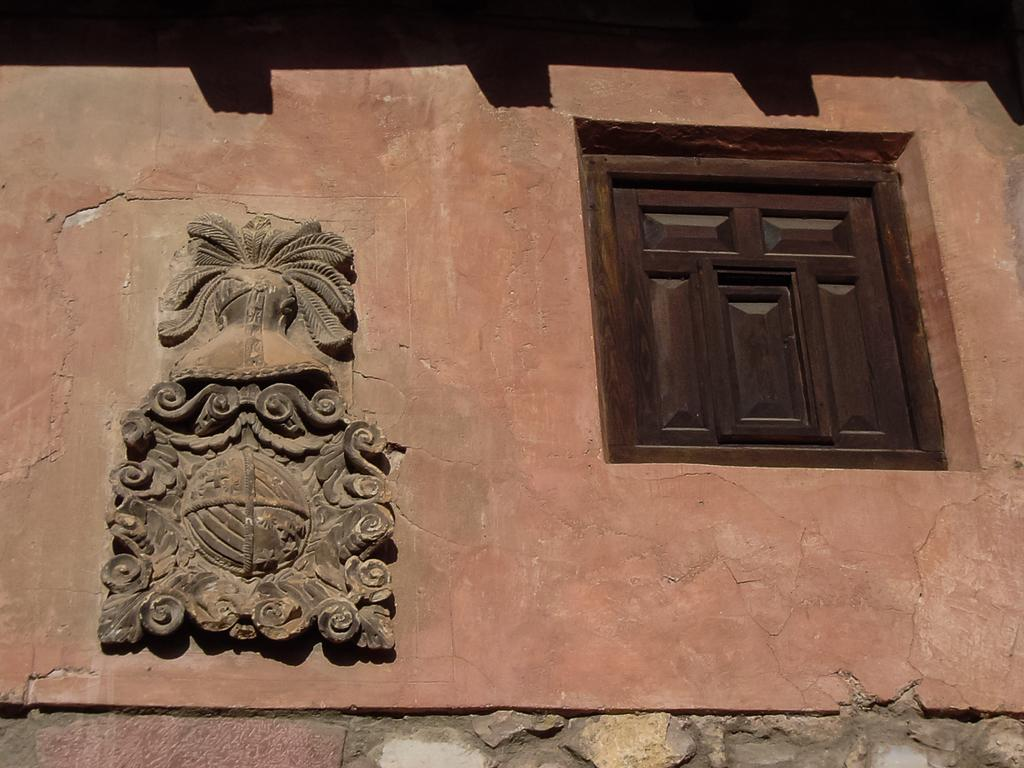What type of structure can be seen in the image? There is a wall in the image. Is there any opening in the wall? Yes, there is a window in the image. What is located near the window? There is a stone carving in the image. What type of bubble can be seen floating near the stone carving in the image? There is no bubble present in the image; it only features a wall, a window, and a stone carving. 